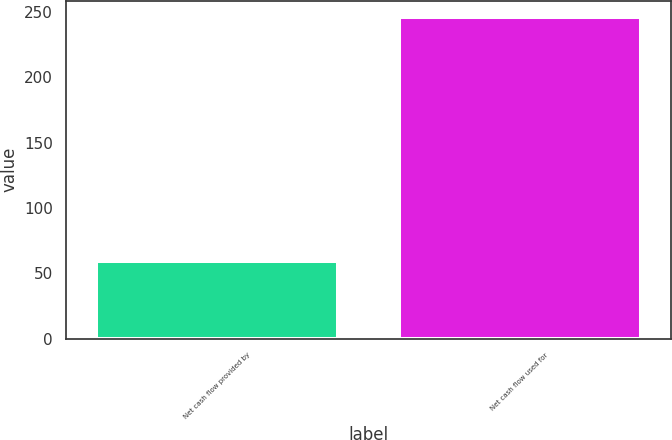Convert chart to OTSL. <chart><loc_0><loc_0><loc_500><loc_500><bar_chart><fcel>Net cash flow provided by<fcel>Net cash flow used for<nl><fcel>59.4<fcel>246.2<nl></chart> 